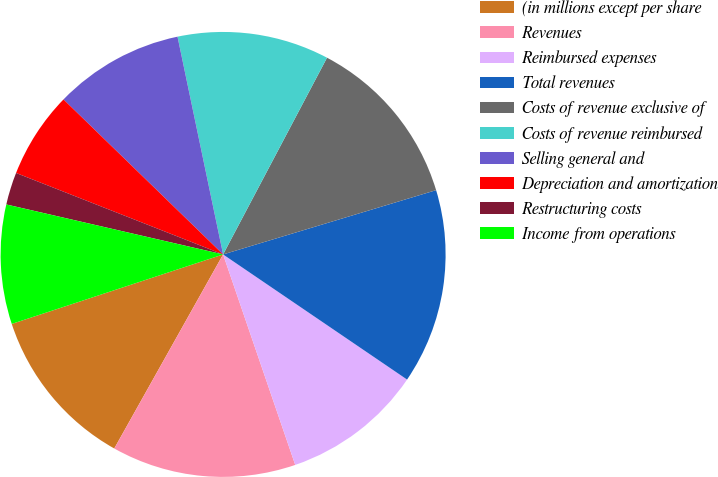Convert chart. <chart><loc_0><loc_0><loc_500><loc_500><pie_chart><fcel>(in millions except per share<fcel>Revenues<fcel>Reimbursed expenses<fcel>Total revenues<fcel>Costs of revenue exclusive of<fcel>Costs of revenue reimbursed<fcel>Selling general and<fcel>Depreciation and amortization<fcel>Restructuring costs<fcel>Income from operations<nl><fcel>11.81%<fcel>13.39%<fcel>10.24%<fcel>14.17%<fcel>12.6%<fcel>11.02%<fcel>9.45%<fcel>6.3%<fcel>2.36%<fcel>8.66%<nl></chart> 